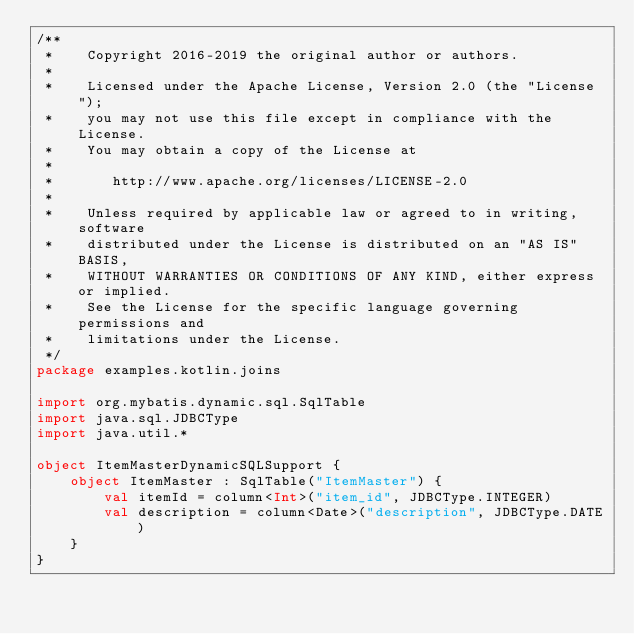<code> <loc_0><loc_0><loc_500><loc_500><_Kotlin_>/**
 *    Copyright 2016-2019 the original author or authors.
 *
 *    Licensed under the Apache License, Version 2.0 (the "License");
 *    you may not use this file except in compliance with the License.
 *    You may obtain a copy of the License at
 *
 *       http://www.apache.org/licenses/LICENSE-2.0
 *
 *    Unless required by applicable law or agreed to in writing, software
 *    distributed under the License is distributed on an "AS IS" BASIS,
 *    WITHOUT WARRANTIES OR CONDITIONS OF ANY KIND, either express or implied.
 *    See the License for the specific language governing permissions and
 *    limitations under the License.
 */
package examples.kotlin.joins

import org.mybatis.dynamic.sql.SqlTable
import java.sql.JDBCType
import java.util.*

object ItemMasterDynamicSQLSupport {
    object ItemMaster : SqlTable("ItemMaster") {
        val itemId = column<Int>("item_id", JDBCType.INTEGER)
        val description = column<Date>("description", JDBCType.DATE)
    }
}
</code> 